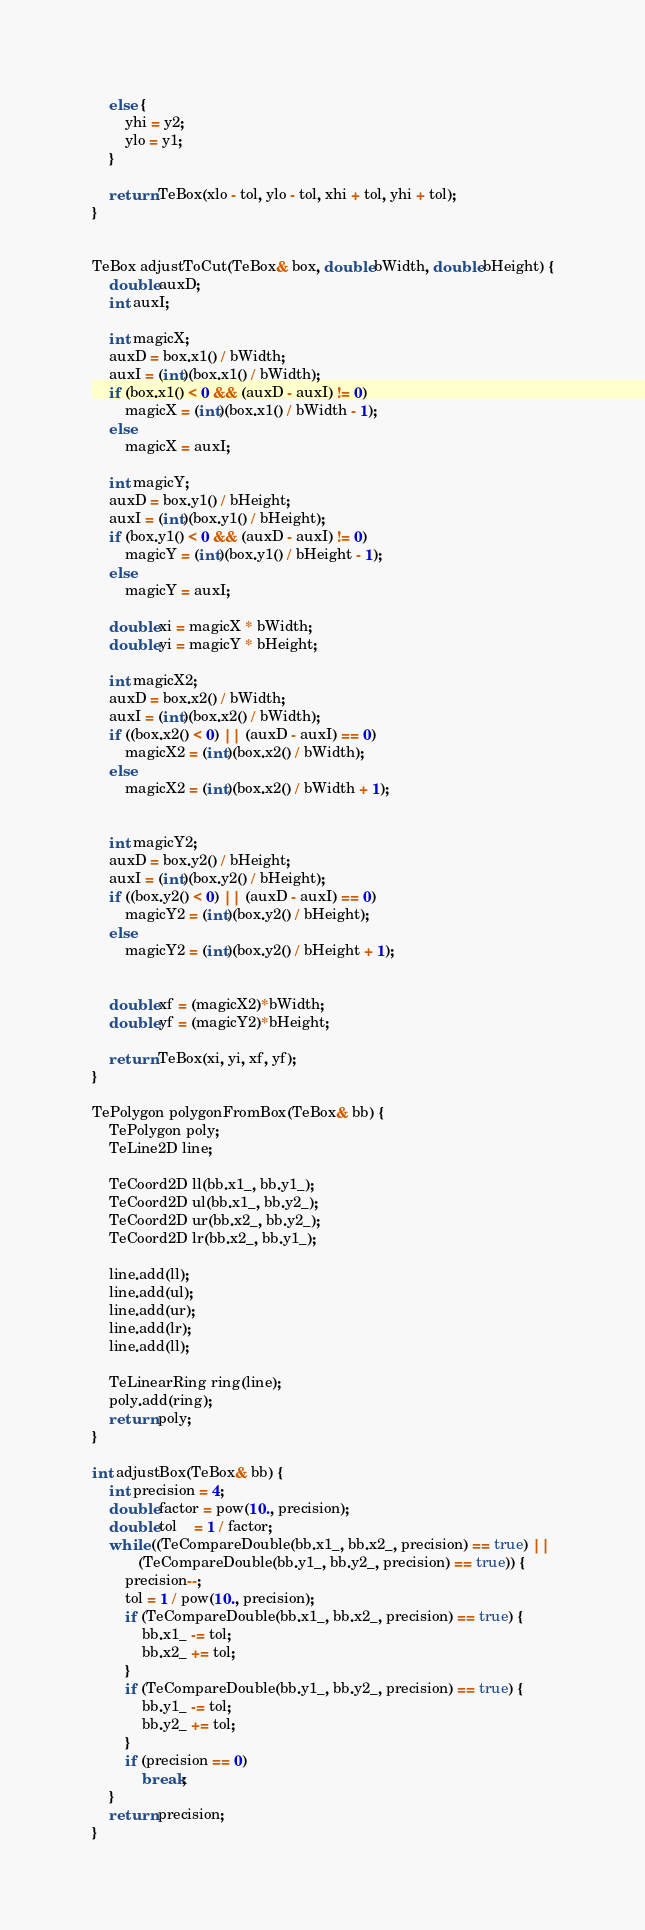<code> <loc_0><loc_0><loc_500><loc_500><_C++_>    else {
        yhi = y2;
        ylo = y1;
    }

    return TeBox(xlo - tol, ylo - tol, xhi + tol, yhi + tol);
}


TeBox adjustToCut(TeBox& box, double bWidth, double bHeight) {
    double auxD;
    int auxI;

    int magicX;
    auxD = box.x1() / bWidth;
    auxI = (int)(box.x1() / bWidth);
    if (box.x1() < 0 && (auxD - auxI) != 0)
        magicX = (int)(box.x1() / bWidth - 1);
    else
        magicX = auxI;

    int magicY;
    auxD = box.y1() / bHeight;
    auxI = (int)(box.y1() / bHeight);
    if (box.y1() < 0 && (auxD - auxI) != 0)
        magicY = (int)(box.y1() / bHeight - 1);
    else
        magicY = auxI;

    double xi = magicX * bWidth;
    double yi = magicY * bHeight;

    int magicX2;
    auxD = box.x2() / bWidth;
    auxI = (int)(box.x2() / bWidth);
    if ((box.x2() < 0) || (auxD - auxI) == 0)
        magicX2 = (int)(box.x2() / bWidth);
    else
        magicX2 = (int)(box.x2() / bWidth + 1);


    int magicY2;
    auxD = box.y2() / bHeight;
    auxI = (int)(box.y2() / bHeight);
    if ((box.y2() < 0) || (auxD - auxI) == 0)
        magicY2 = (int)(box.y2() / bHeight);
    else
        magicY2 = (int)(box.y2() / bHeight + 1);


    double xf = (magicX2)*bWidth;
    double yf = (magicY2)*bHeight;

    return TeBox(xi, yi, xf, yf);
}

TePolygon polygonFromBox(TeBox& bb) {
    TePolygon poly;
    TeLine2D line;

    TeCoord2D ll(bb.x1_, bb.y1_);
    TeCoord2D ul(bb.x1_, bb.y2_);
    TeCoord2D ur(bb.x2_, bb.y2_);
    TeCoord2D lr(bb.x2_, bb.y1_);

    line.add(ll);
    line.add(ul);
    line.add(ur);
    line.add(lr);
    line.add(ll);

    TeLinearRing ring(line);
    poly.add(ring);
    return poly;
}

int adjustBox(TeBox& bb) {
    int precision = 4;
    double factor = pow(10., precision);
    double tol    = 1 / factor;
    while ((TeCompareDouble(bb.x1_, bb.x2_, precision) == true) ||
           (TeCompareDouble(bb.y1_, bb.y2_, precision) == true)) {
        precision--;
        tol = 1 / pow(10., precision);
        if (TeCompareDouble(bb.x1_, bb.x2_, precision) == true) {
            bb.x1_ -= tol;
            bb.x2_ += tol;
        }
        if (TeCompareDouble(bb.y1_, bb.y2_, precision) == true) {
            bb.y1_ -= tol;
            bb.y2_ += tol;
        }
        if (precision == 0)
            break;
    }
    return precision;
}
</code> 